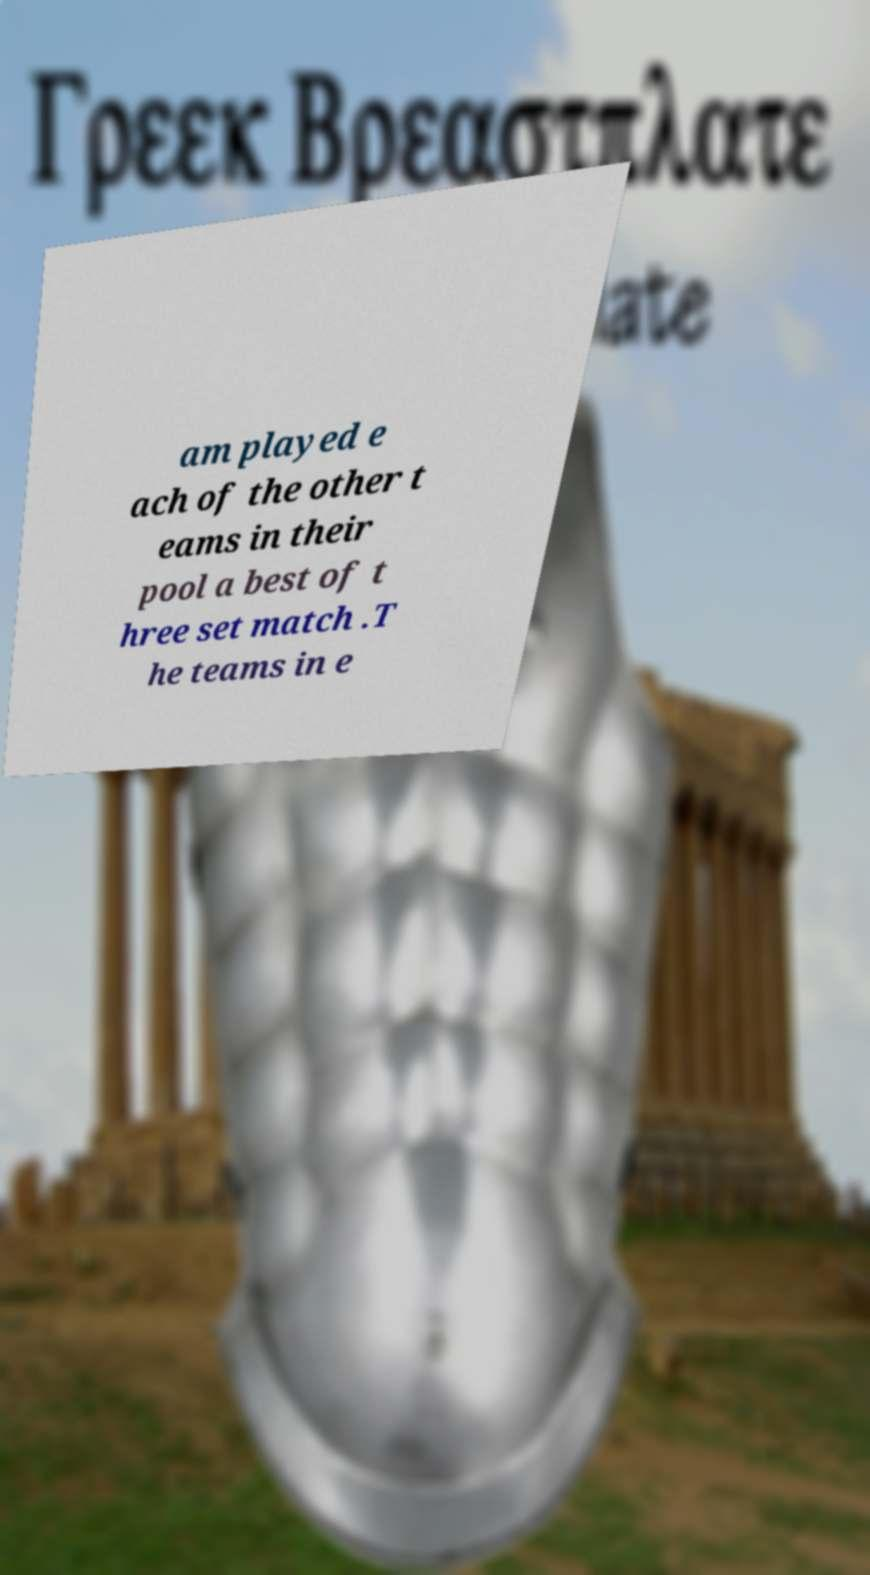Can you accurately transcribe the text from the provided image for me? am played e ach of the other t eams in their pool a best of t hree set match .T he teams in e 